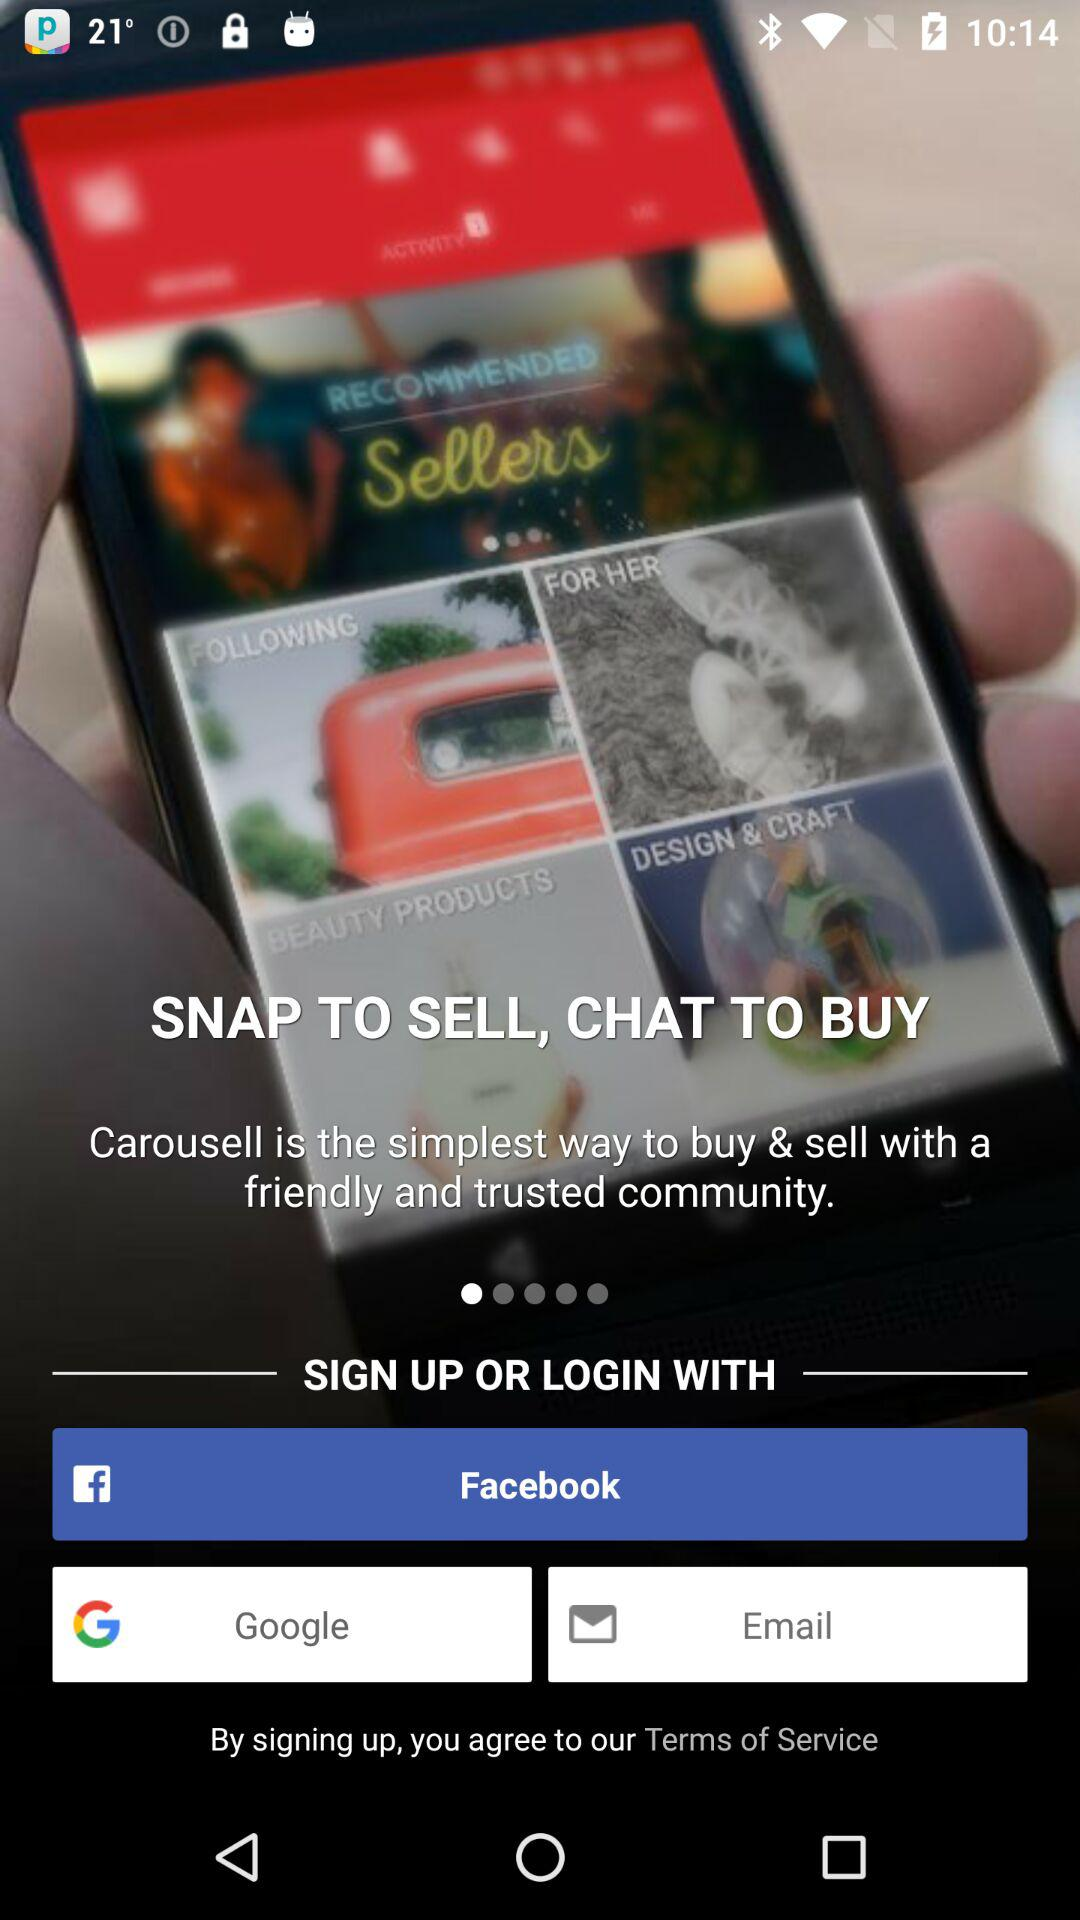What is the name of the application? The application name is "Carousell". 